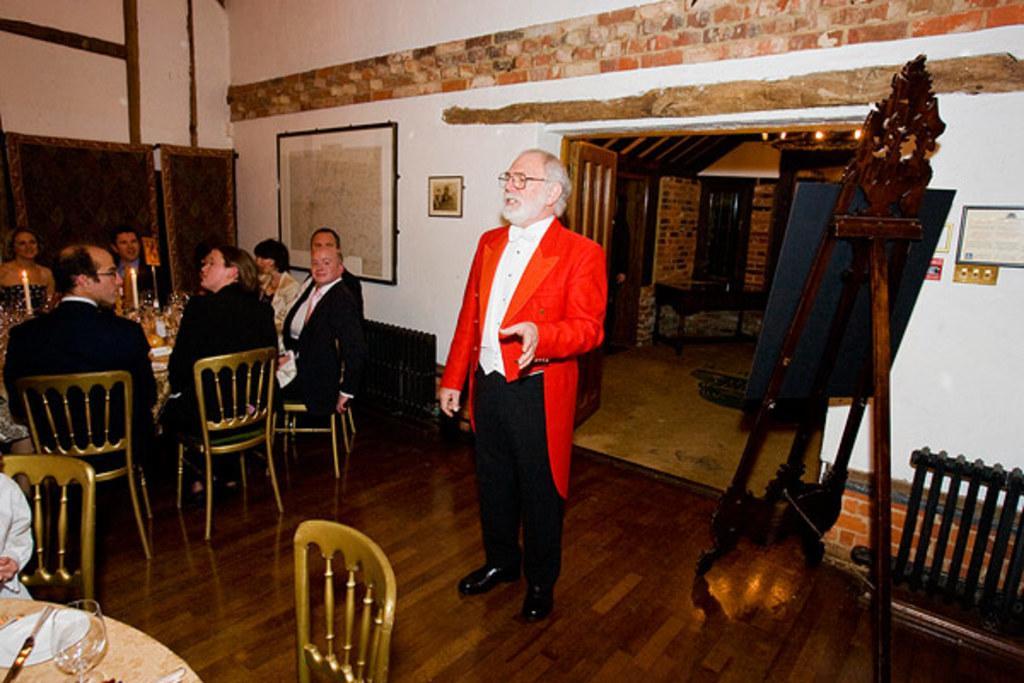Please provide a concise description of this image. There is a man in this picture wearing a red color coat. In front of him, there is a table and chairs. In the background, there are some members sitting around a table on which some candles were placed. We can observe a glass and knife on this table. In the background, there is a board here. We can observe a notice chart here. 